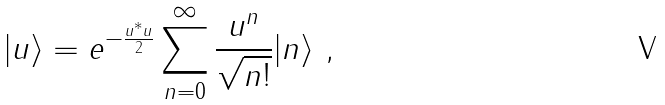Convert formula to latex. <formula><loc_0><loc_0><loc_500><loc_500>| u \rangle = e ^ { - \frac { u ^ { * } u } { 2 } } \sum _ { n = 0 } ^ { \infty } \frac { u ^ { n } } { \sqrt { n ! } } | n \rangle \ ,</formula> 